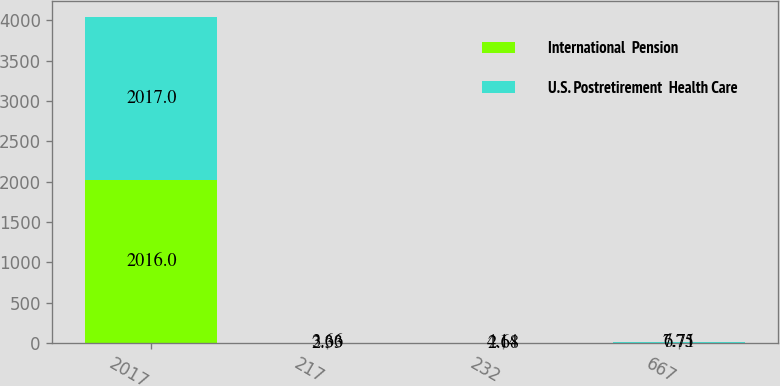Convert chart to OTSL. <chart><loc_0><loc_0><loc_500><loc_500><stacked_bar_chart><ecel><fcel>2017<fcel>217<fcel>232<fcel>667<nl><fcel>International  Pension<fcel>2016<fcel>2.33<fcel>2.68<fcel>6.71<nl><fcel>U.S. Postretirement  Health Care<fcel>2017<fcel>3.66<fcel>4.14<fcel>7.75<nl></chart> 